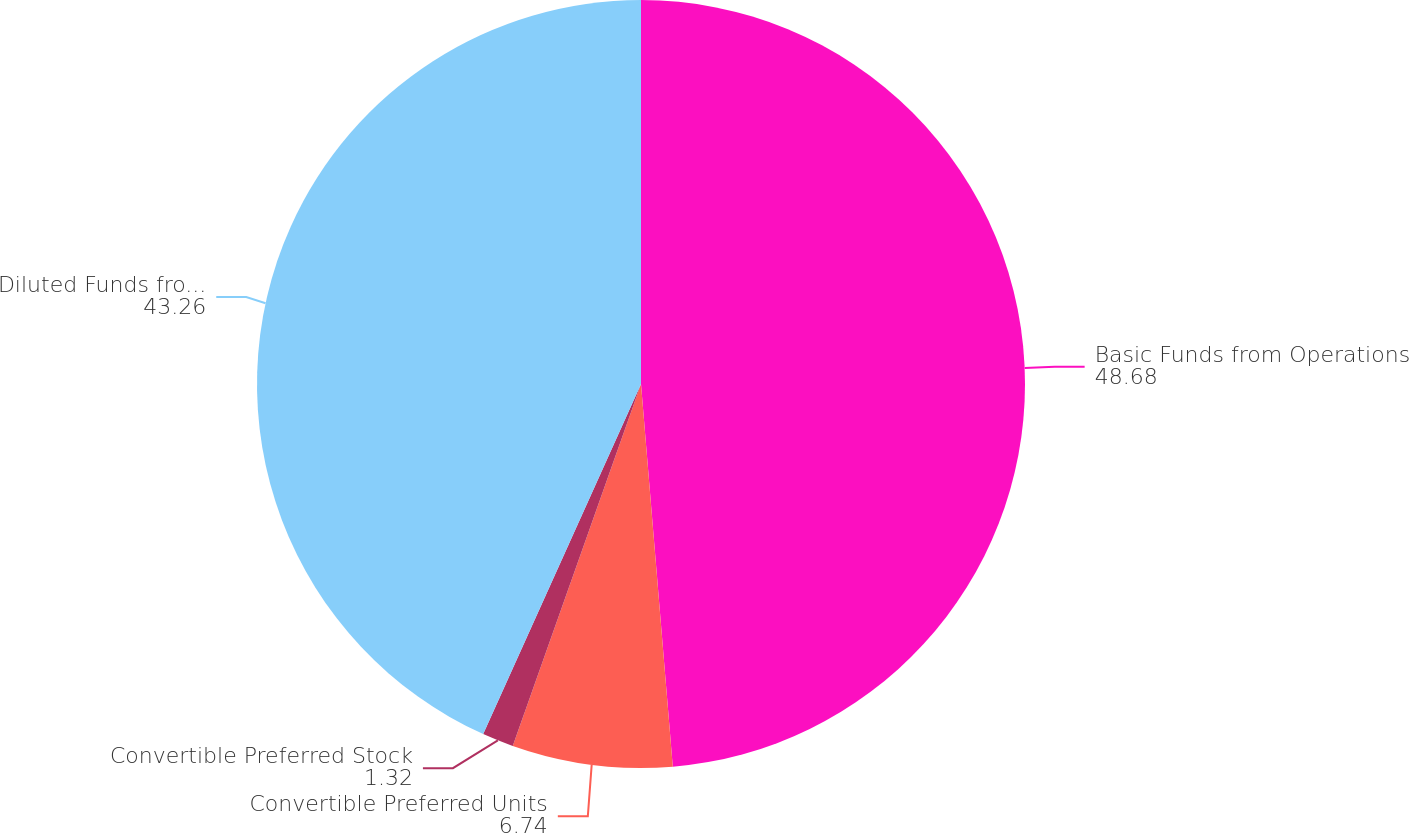Convert chart to OTSL. <chart><loc_0><loc_0><loc_500><loc_500><pie_chart><fcel>Basic Funds from Operations<fcel>Convertible Preferred Units<fcel>Convertible Preferred Stock<fcel>Diluted Funds from Operations<nl><fcel>48.68%<fcel>6.74%<fcel>1.32%<fcel>43.26%<nl></chart> 